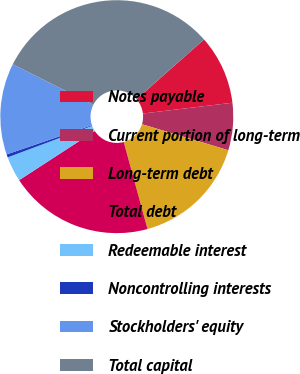Convert chart. <chart><loc_0><loc_0><loc_500><loc_500><pie_chart><fcel>Notes payable<fcel>Current portion of long-term<fcel>Long-term debt<fcel>Total debt<fcel>Redeemable interest<fcel>Noncontrolling interests<fcel>Stockholders' equity<fcel>Total capital<nl><fcel>9.62%<fcel>6.56%<fcel>16.1%<fcel>20.07%<fcel>3.49%<fcel>0.43%<fcel>12.68%<fcel>31.04%<nl></chart> 